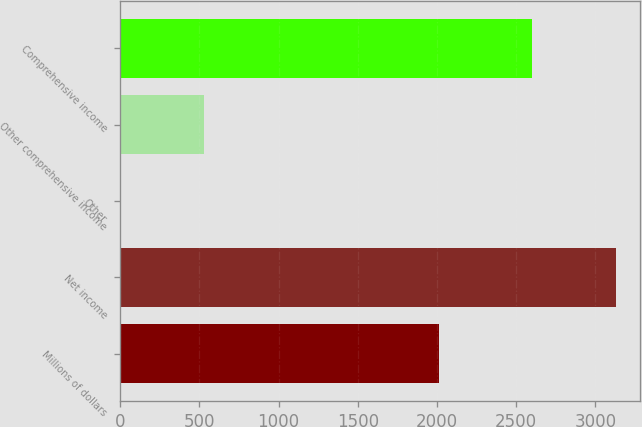Convert chart to OTSL. <chart><loc_0><loc_0><loc_500><loc_500><bar_chart><fcel>Millions of dollars<fcel>Net income<fcel>Other<fcel>Other comprehensive income<fcel>Comprehensive income<nl><fcel>2012<fcel>3127.4<fcel>3<fcel>531.4<fcel>2599<nl></chart> 